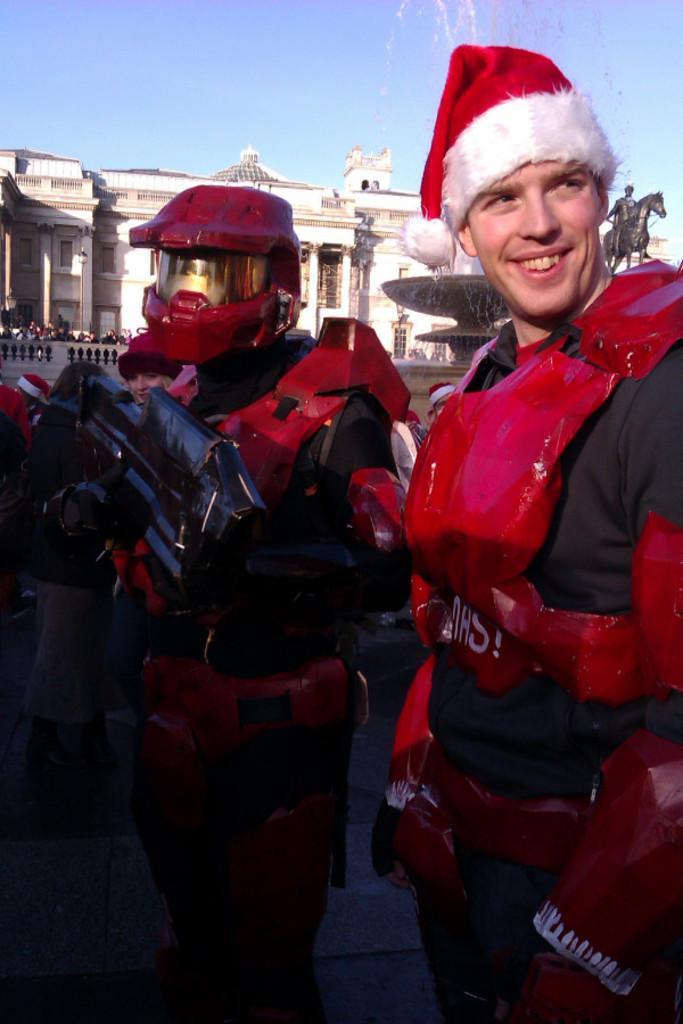Can you describe this image briefly? In this picture there is a man who is wearing Santa Claus dress, beside him I can see the man who is wearing helmet and armor. In the back I can see the building. At the top I can see the sky and clouds. 